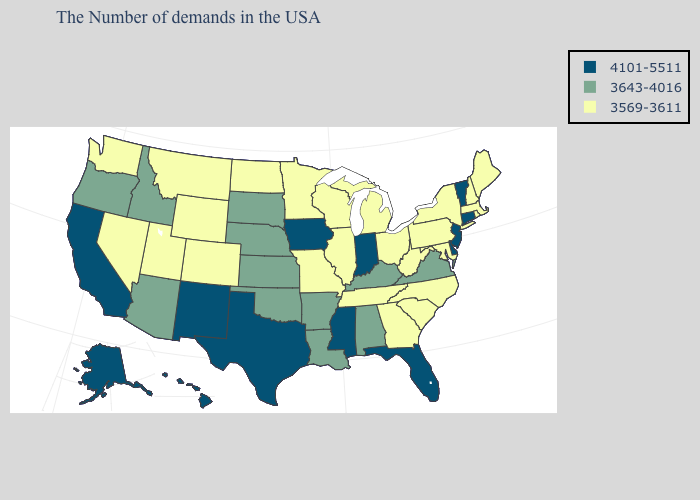What is the lowest value in the USA?
Give a very brief answer. 3569-3611. How many symbols are there in the legend?
Give a very brief answer. 3. Does Idaho have the same value as Virginia?
Write a very short answer. Yes. What is the highest value in the USA?
Quick response, please. 4101-5511. Among the states that border Wyoming , does Utah have the lowest value?
Short answer required. Yes. What is the lowest value in the MidWest?
Short answer required. 3569-3611. Name the states that have a value in the range 3643-4016?
Answer briefly. Virginia, Kentucky, Alabama, Louisiana, Arkansas, Kansas, Nebraska, Oklahoma, South Dakota, Arizona, Idaho, Oregon. What is the value of Michigan?
Answer briefly. 3569-3611. What is the value of Montana?
Concise answer only. 3569-3611. What is the highest value in the USA?
Short answer required. 4101-5511. How many symbols are there in the legend?
Keep it brief. 3. What is the highest value in states that border Indiana?
Answer briefly. 3643-4016. Among the states that border North Carolina , does Virginia have the highest value?
Short answer required. Yes. Does West Virginia have the highest value in the South?
Concise answer only. No. What is the value of Indiana?
Short answer required. 4101-5511. 